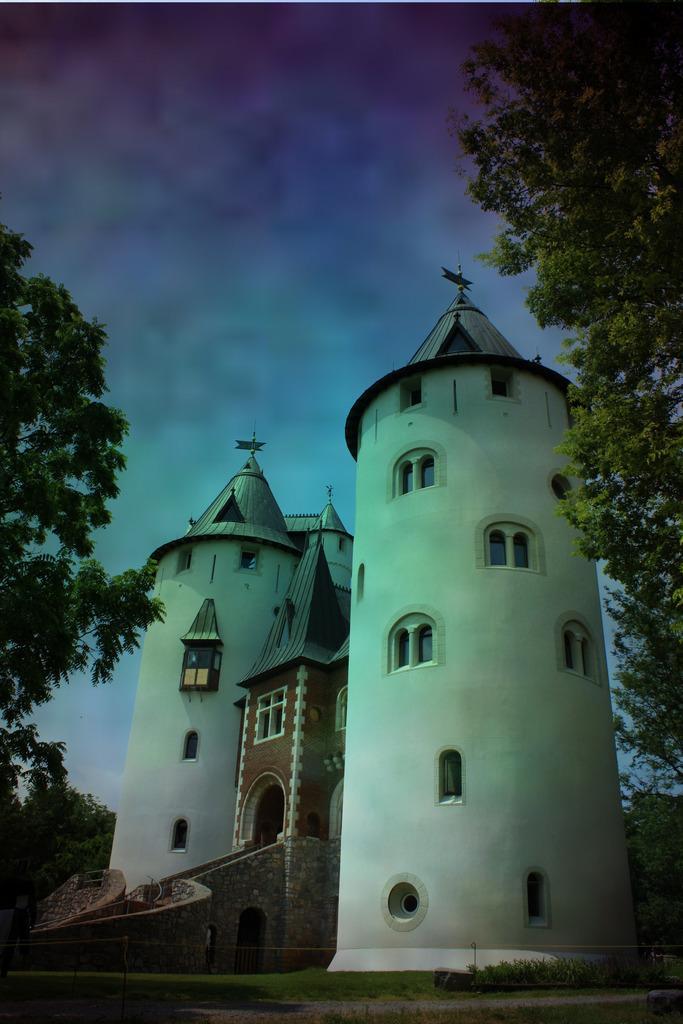Please provide a concise description of this image. In the picture I can see a castle, trees and the cloudy sky in the background. 